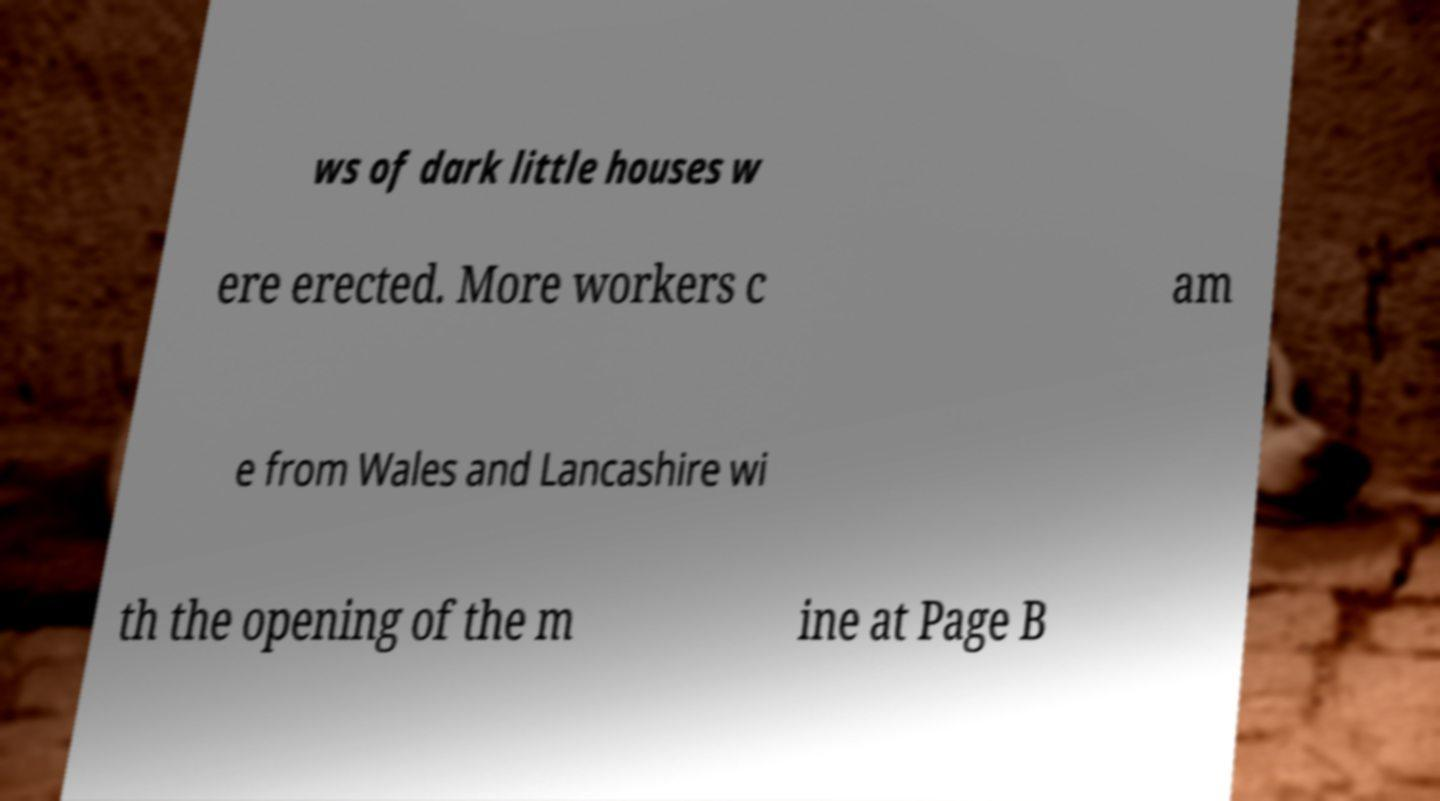Can you read and provide the text displayed in the image?This photo seems to have some interesting text. Can you extract and type it out for me? ws of dark little houses w ere erected. More workers c am e from Wales and Lancashire wi th the opening of the m ine at Page B 